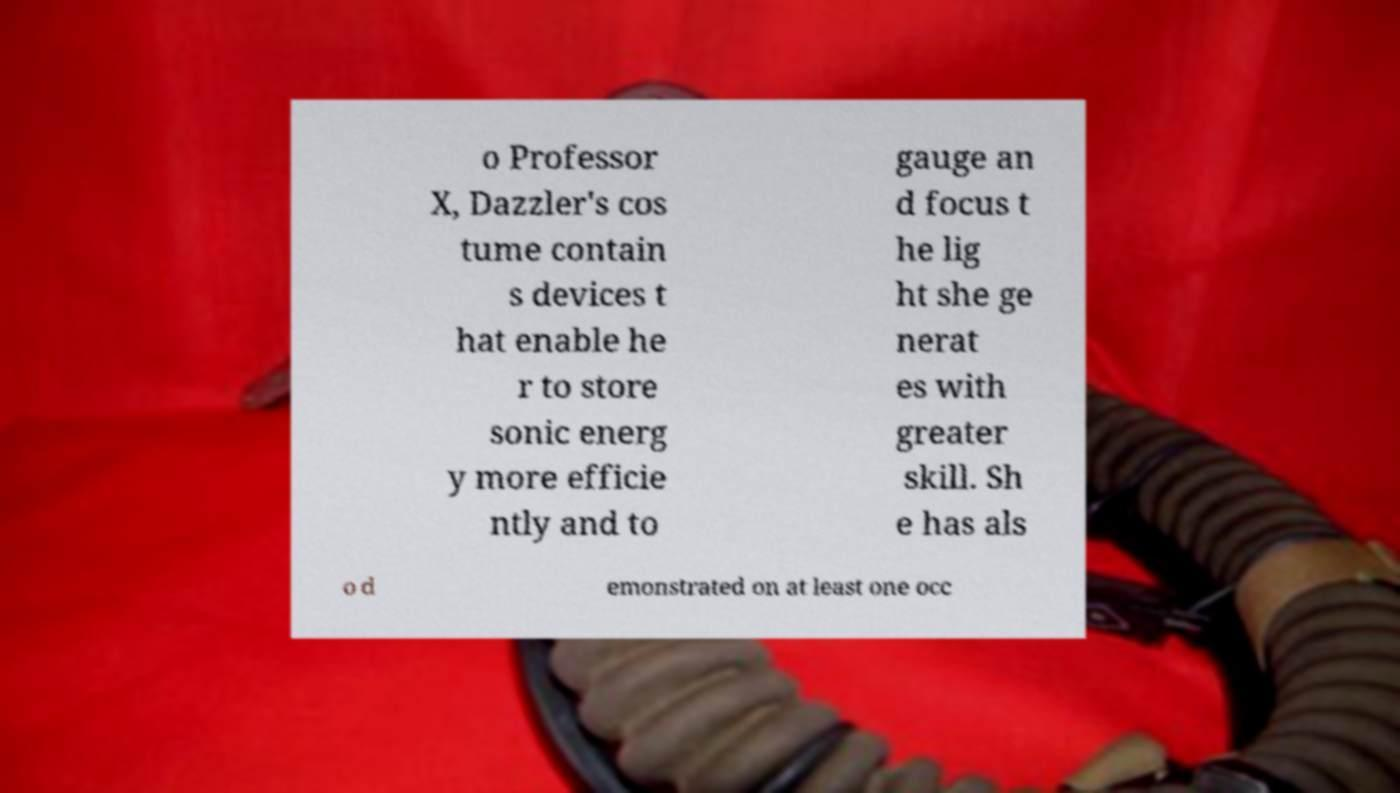Please read and relay the text visible in this image. What does it say? o Professor X, Dazzler's cos tume contain s devices t hat enable he r to store sonic energ y more efficie ntly and to gauge an d focus t he lig ht she ge nerat es with greater skill. Sh e has als o d emonstrated on at least one occ 